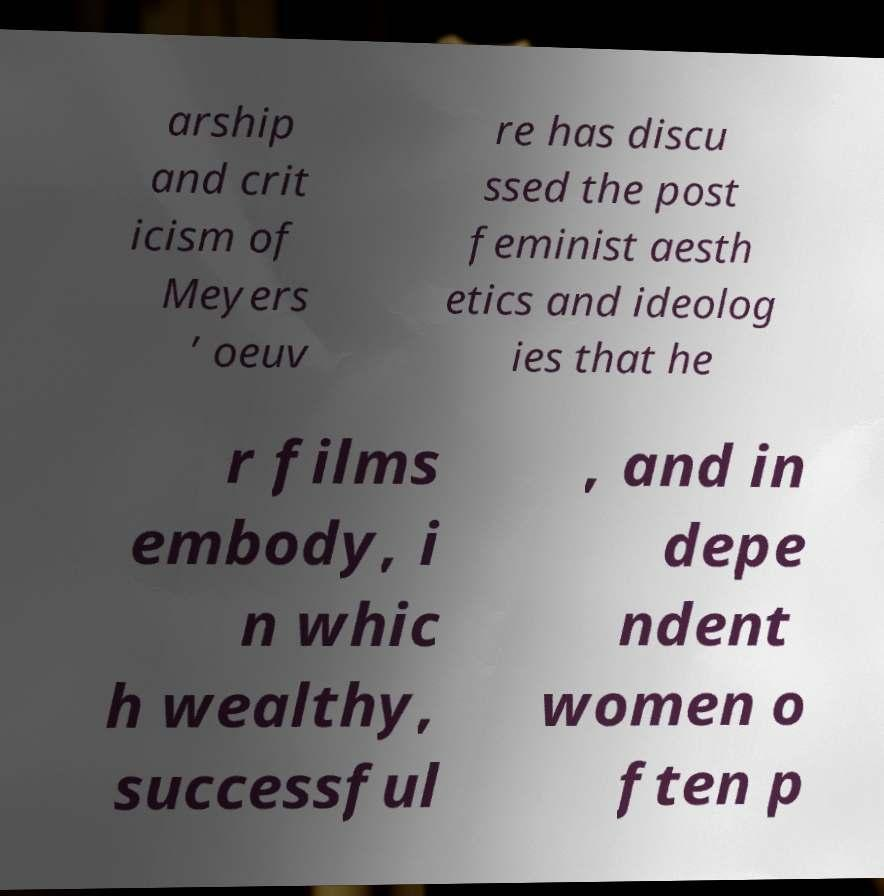Could you assist in decoding the text presented in this image and type it out clearly? arship and crit icism of Meyers ’ oeuv re has discu ssed the post feminist aesth etics and ideolog ies that he r films embody, i n whic h wealthy, successful , and in depe ndent women o ften p 